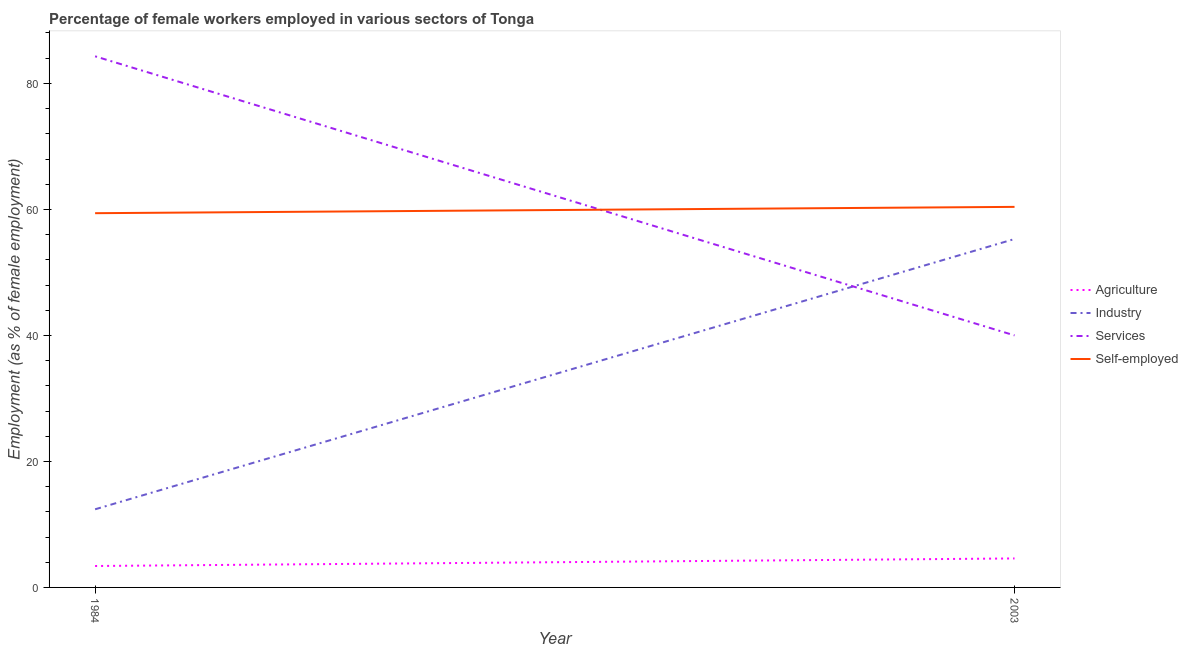How many different coloured lines are there?
Your answer should be compact. 4. Does the line corresponding to percentage of self employed female workers intersect with the line corresponding to percentage of female workers in agriculture?
Your answer should be compact. No. Across all years, what is the maximum percentage of self employed female workers?
Ensure brevity in your answer.  60.4. Across all years, what is the minimum percentage of self employed female workers?
Make the answer very short. 59.4. In which year was the percentage of female workers in services maximum?
Your answer should be very brief. 1984. What is the difference between the percentage of female workers in agriculture in 1984 and that in 2003?
Your answer should be compact. -1.2. What is the difference between the percentage of self employed female workers in 1984 and the percentage of female workers in agriculture in 2003?
Offer a terse response. 54.8. What is the average percentage of female workers in services per year?
Your answer should be compact. 62.15. In the year 1984, what is the difference between the percentage of female workers in industry and percentage of female workers in agriculture?
Your answer should be compact. 9. What is the ratio of the percentage of female workers in industry in 1984 to that in 2003?
Your answer should be very brief. 0.22. Is the percentage of female workers in agriculture in 1984 less than that in 2003?
Give a very brief answer. Yes. Is it the case that in every year, the sum of the percentage of female workers in services and percentage of female workers in industry is greater than the sum of percentage of self employed female workers and percentage of female workers in agriculture?
Offer a very short reply. Yes. Does the percentage of self employed female workers monotonically increase over the years?
Ensure brevity in your answer.  Yes. How many lines are there?
Provide a succinct answer. 4. How many years are there in the graph?
Offer a terse response. 2. What is the difference between two consecutive major ticks on the Y-axis?
Offer a terse response. 20. Does the graph contain any zero values?
Ensure brevity in your answer.  No. Does the graph contain grids?
Make the answer very short. No. Where does the legend appear in the graph?
Offer a very short reply. Center right. How many legend labels are there?
Your answer should be compact. 4. How are the legend labels stacked?
Your response must be concise. Vertical. What is the title of the graph?
Your answer should be very brief. Percentage of female workers employed in various sectors of Tonga. What is the label or title of the X-axis?
Your response must be concise. Year. What is the label or title of the Y-axis?
Offer a very short reply. Employment (as % of female employment). What is the Employment (as % of female employment) in Agriculture in 1984?
Give a very brief answer. 3.4. What is the Employment (as % of female employment) of Industry in 1984?
Keep it short and to the point. 12.4. What is the Employment (as % of female employment) of Services in 1984?
Offer a very short reply. 84.3. What is the Employment (as % of female employment) in Self-employed in 1984?
Offer a very short reply. 59.4. What is the Employment (as % of female employment) of Agriculture in 2003?
Provide a short and direct response. 4.6. What is the Employment (as % of female employment) in Industry in 2003?
Your answer should be compact. 55.3. What is the Employment (as % of female employment) of Services in 2003?
Make the answer very short. 40. What is the Employment (as % of female employment) in Self-employed in 2003?
Make the answer very short. 60.4. Across all years, what is the maximum Employment (as % of female employment) of Agriculture?
Provide a succinct answer. 4.6. Across all years, what is the maximum Employment (as % of female employment) of Industry?
Your response must be concise. 55.3. Across all years, what is the maximum Employment (as % of female employment) in Services?
Provide a short and direct response. 84.3. Across all years, what is the maximum Employment (as % of female employment) in Self-employed?
Offer a very short reply. 60.4. Across all years, what is the minimum Employment (as % of female employment) of Agriculture?
Keep it short and to the point. 3.4. Across all years, what is the minimum Employment (as % of female employment) in Industry?
Your response must be concise. 12.4. Across all years, what is the minimum Employment (as % of female employment) of Services?
Make the answer very short. 40. Across all years, what is the minimum Employment (as % of female employment) of Self-employed?
Ensure brevity in your answer.  59.4. What is the total Employment (as % of female employment) in Agriculture in the graph?
Offer a very short reply. 8. What is the total Employment (as % of female employment) of Industry in the graph?
Your answer should be very brief. 67.7. What is the total Employment (as % of female employment) in Services in the graph?
Your answer should be very brief. 124.3. What is the total Employment (as % of female employment) in Self-employed in the graph?
Keep it short and to the point. 119.8. What is the difference between the Employment (as % of female employment) of Agriculture in 1984 and that in 2003?
Give a very brief answer. -1.2. What is the difference between the Employment (as % of female employment) of Industry in 1984 and that in 2003?
Keep it short and to the point. -42.9. What is the difference between the Employment (as % of female employment) of Services in 1984 and that in 2003?
Make the answer very short. 44.3. What is the difference between the Employment (as % of female employment) of Self-employed in 1984 and that in 2003?
Ensure brevity in your answer.  -1. What is the difference between the Employment (as % of female employment) in Agriculture in 1984 and the Employment (as % of female employment) in Industry in 2003?
Your answer should be compact. -51.9. What is the difference between the Employment (as % of female employment) of Agriculture in 1984 and the Employment (as % of female employment) of Services in 2003?
Provide a succinct answer. -36.6. What is the difference between the Employment (as % of female employment) of Agriculture in 1984 and the Employment (as % of female employment) of Self-employed in 2003?
Provide a succinct answer. -57. What is the difference between the Employment (as % of female employment) of Industry in 1984 and the Employment (as % of female employment) of Services in 2003?
Offer a terse response. -27.6. What is the difference between the Employment (as % of female employment) of Industry in 1984 and the Employment (as % of female employment) of Self-employed in 2003?
Make the answer very short. -48. What is the difference between the Employment (as % of female employment) in Services in 1984 and the Employment (as % of female employment) in Self-employed in 2003?
Your response must be concise. 23.9. What is the average Employment (as % of female employment) in Agriculture per year?
Give a very brief answer. 4. What is the average Employment (as % of female employment) in Industry per year?
Provide a succinct answer. 33.85. What is the average Employment (as % of female employment) of Services per year?
Make the answer very short. 62.15. What is the average Employment (as % of female employment) in Self-employed per year?
Ensure brevity in your answer.  59.9. In the year 1984, what is the difference between the Employment (as % of female employment) in Agriculture and Employment (as % of female employment) in Industry?
Offer a terse response. -9. In the year 1984, what is the difference between the Employment (as % of female employment) of Agriculture and Employment (as % of female employment) of Services?
Your answer should be compact. -80.9. In the year 1984, what is the difference between the Employment (as % of female employment) of Agriculture and Employment (as % of female employment) of Self-employed?
Offer a very short reply. -56. In the year 1984, what is the difference between the Employment (as % of female employment) of Industry and Employment (as % of female employment) of Services?
Offer a very short reply. -71.9. In the year 1984, what is the difference between the Employment (as % of female employment) of Industry and Employment (as % of female employment) of Self-employed?
Your answer should be compact. -47. In the year 1984, what is the difference between the Employment (as % of female employment) in Services and Employment (as % of female employment) in Self-employed?
Provide a succinct answer. 24.9. In the year 2003, what is the difference between the Employment (as % of female employment) in Agriculture and Employment (as % of female employment) in Industry?
Ensure brevity in your answer.  -50.7. In the year 2003, what is the difference between the Employment (as % of female employment) of Agriculture and Employment (as % of female employment) of Services?
Make the answer very short. -35.4. In the year 2003, what is the difference between the Employment (as % of female employment) in Agriculture and Employment (as % of female employment) in Self-employed?
Keep it short and to the point. -55.8. In the year 2003, what is the difference between the Employment (as % of female employment) of Industry and Employment (as % of female employment) of Self-employed?
Make the answer very short. -5.1. In the year 2003, what is the difference between the Employment (as % of female employment) in Services and Employment (as % of female employment) in Self-employed?
Offer a very short reply. -20.4. What is the ratio of the Employment (as % of female employment) in Agriculture in 1984 to that in 2003?
Your answer should be very brief. 0.74. What is the ratio of the Employment (as % of female employment) in Industry in 1984 to that in 2003?
Make the answer very short. 0.22. What is the ratio of the Employment (as % of female employment) of Services in 1984 to that in 2003?
Provide a short and direct response. 2.11. What is the ratio of the Employment (as % of female employment) in Self-employed in 1984 to that in 2003?
Offer a terse response. 0.98. What is the difference between the highest and the second highest Employment (as % of female employment) of Industry?
Your response must be concise. 42.9. What is the difference between the highest and the second highest Employment (as % of female employment) of Services?
Ensure brevity in your answer.  44.3. What is the difference between the highest and the lowest Employment (as % of female employment) of Industry?
Keep it short and to the point. 42.9. What is the difference between the highest and the lowest Employment (as % of female employment) of Services?
Give a very brief answer. 44.3. 